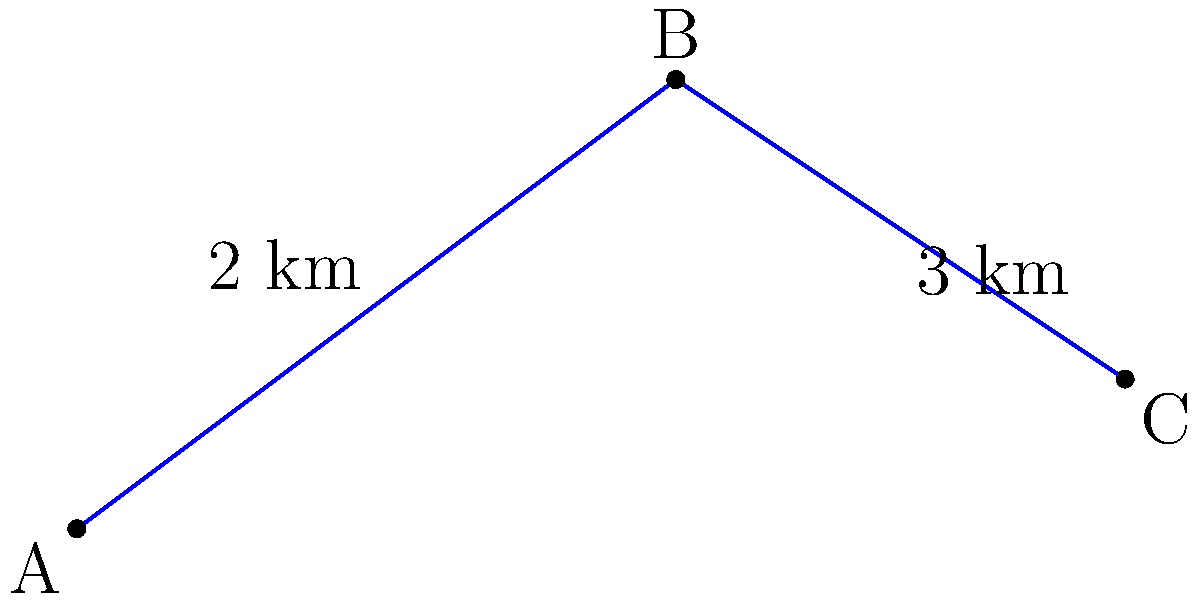On your daily bus route, you pass three consecutive stops: A, B, and C. The distance between A and B is 2 km, and the distance between B and C is 3 km. If the angle formed by these three points is 135°, what is the direct distance between stops A and C? To solve this problem, we can use the law of cosines. Let's approach this step-by-step:

1) First, let's recall the law of cosines:
   $c^2 = a^2 + b^2 - 2ab \cos(C)$

   Where $c$ is the side we're looking for (AC), $a$ and $b$ are the known sides (AB and BC), and $C$ is the angle between them.

2) We know:
   $a = 2$ km (distance AB)
   $b = 3$ km (distance BC)
   $C = 135°$

3) Let's substitute these values into the formula:
   $AC^2 = 2^2 + 3^2 - 2(2)(3) \cos(135°)$

4) Simplify:
   $AC^2 = 4 + 9 - 12 \cos(135°)$

5) Calculate $\cos(135°)$:
   $\cos(135°) = -\frac{\sqrt{2}}{2}$

6) Substitute this value:
   $AC^2 = 4 + 9 - 12(-\frac{\sqrt{2}}{2})$
   $AC^2 = 13 + 6\sqrt{2}$

7) Take the square root of both sides:
   $AC = \sqrt{13 + 6\sqrt{2}}$

8) This can be simplified to:
   $AC = \sqrt{13 + 6\sqrt{2}} \approx 5$ km

Therefore, the direct distance between stops A and C is approximately 5 km.
Answer: $5$ km 